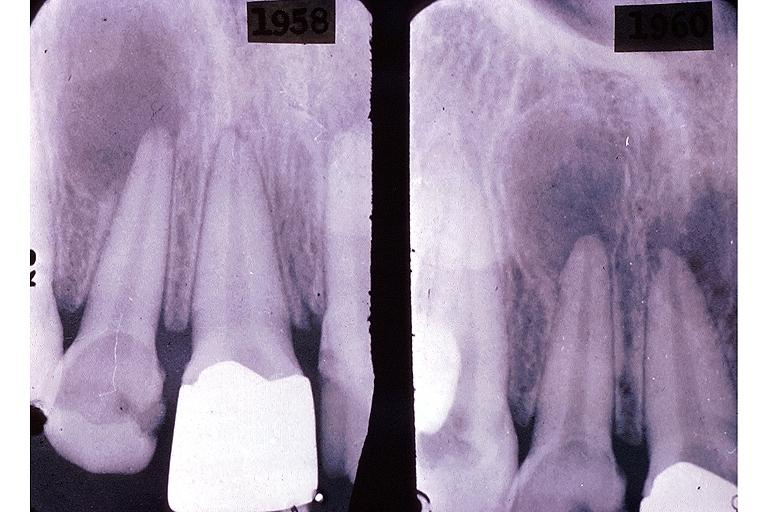s gastrointestinal present?
Answer the question using a single word or phrase. No 